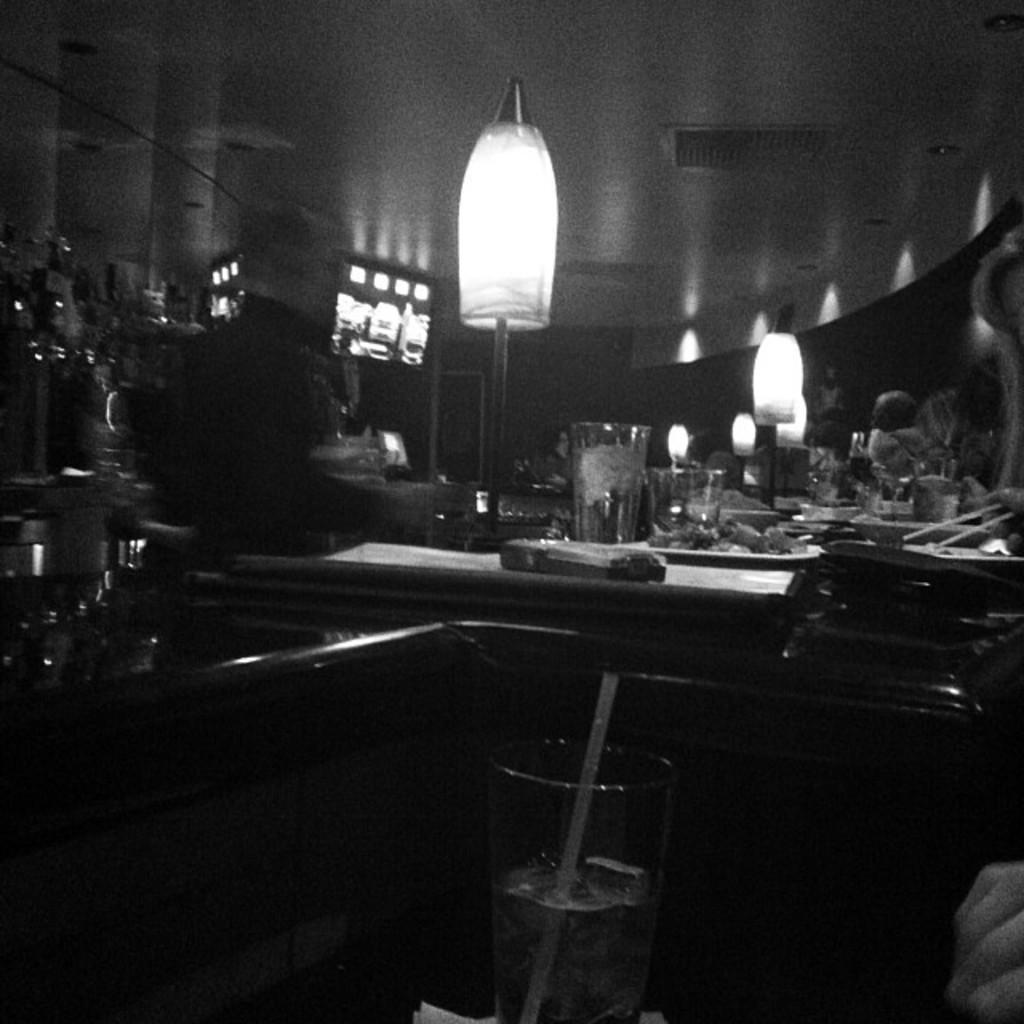Please provide a concise description of this image. In this black and white picture a person is standing near the table having few lamps, plates, glasses and few objects on it. Plate is having some food in it. Bottom of image there is a glass having some drink and straw in it. Behind there is a chair. 